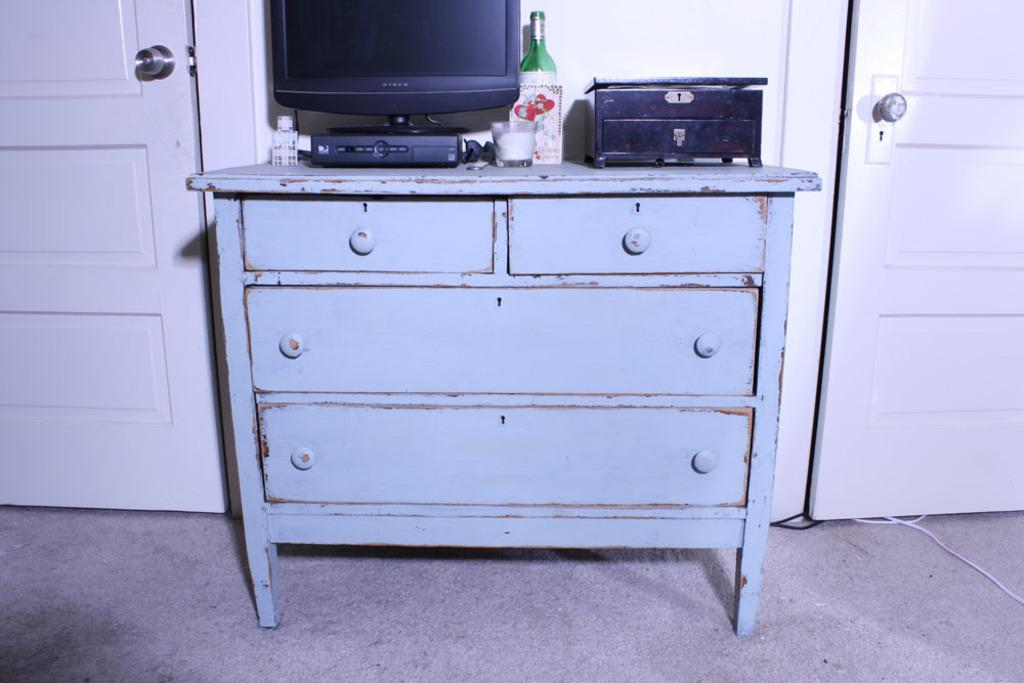What type of furniture is present in the image? There is a table with drawers in the image. What electronic device is on the table? There is a television on the table. What additional device is on the table? There is a setup box on the table. What beverage-related items are on the table? There is a wine bottle and a glass on the table. How many doors are visible in the image? There are two doors on either side of the table. Is there a volcano erupting in the image? No, there is no volcano or any indication of an eruption in the image. What type of chair is present in the image? There is no chair mentioned or visible in the image. 